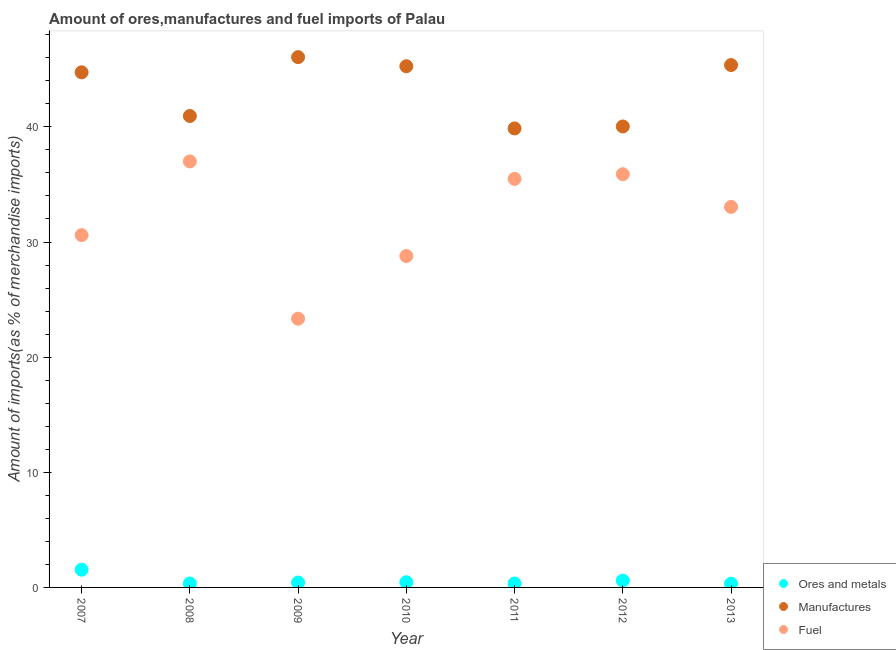What is the percentage of ores and metals imports in 2012?
Your answer should be very brief. 0.59. Across all years, what is the maximum percentage of ores and metals imports?
Give a very brief answer. 1.54. Across all years, what is the minimum percentage of ores and metals imports?
Give a very brief answer. 0.32. In which year was the percentage of manufactures imports maximum?
Ensure brevity in your answer.  2009. In which year was the percentage of ores and metals imports minimum?
Your answer should be compact. 2013. What is the total percentage of manufactures imports in the graph?
Your answer should be very brief. 302.28. What is the difference between the percentage of ores and metals imports in 2012 and that in 2013?
Make the answer very short. 0.27. What is the difference between the percentage of manufactures imports in 2009 and the percentage of ores and metals imports in 2008?
Give a very brief answer. 45.71. What is the average percentage of fuel imports per year?
Offer a very short reply. 32.02. In the year 2007, what is the difference between the percentage of manufactures imports and percentage of ores and metals imports?
Provide a succinct answer. 43.2. In how many years, is the percentage of fuel imports greater than 18 %?
Give a very brief answer. 7. What is the ratio of the percentage of ores and metals imports in 2009 to that in 2012?
Offer a terse response. 0.71. What is the difference between the highest and the second highest percentage of fuel imports?
Keep it short and to the point. 1.11. What is the difference between the highest and the lowest percentage of ores and metals imports?
Provide a succinct answer. 1.22. Is the sum of the percentage of ores and metals imports in 2010 and 2011 greater than the maximum percentage of manufactures imports across all years?
Your response must be concise. No. Is the percentage of fuel imports strictly greater than the percentage of ores and metals imports over the years?
Provide a succinct answer. Yes. Is the percentage of fuel imports strictly less than the percentage of manufactures imports over the years?
Your answer should be very brief. Yes. How many dotlines are there?
Give a very brief answer. 3. Are the values on the major ticks of Y-axis written in scientific E-notation?
Provide a short and direct response. No. How many legend labels are there?
Keep it short and to the point. 3. What is the title of the graph?
Provide a succinct answer. Amount of ores,manufactures and fuel imports of Palau. What is the label or title of the Y-axis?
Offer a terse response. Amount of imports(as % of merchandise imports). What is the Amount of imports(as % of merchandise imports) in Ores and metals in 2007?
Offer a terse response. 1.54. What is the Amount of imports(as % of merchandise imports) of Manufactures in 2007?
Make the answer very short. 44.74. What is the Amount of imports(as % of merchandise imports) in Fuel in 2007?
Your answer should be compact. 30.6. What is the Amount of imports(as % of merchandise imports) in Ores and metals in 2008?
Offer a very short reply. 0.34. What is the Amount of imports(as % of merchandise imports) of Manufactures in 2008?
Make the answer very short. 40.95. What is the Amount of imports(as % of merchandise imports) of Fuel in 2008?
Keep it short and to the point. 37. What is the Amount of imports(as % of merchandise imports) of Ores and metals in 2009?
Provide a succinct answer. 0.42. What is the Amount of imports(as % of merchandise imports) in Manufactures in 2009?
Make the answer very short. 46.06. What is the Amount of imports(as % of merchandise imports) in Fuel in 2009?
Your answer should be very brief. 23.34. What is the Amount of imports(as % of merchandise imports) in Ores and metals in 2010?
Provide a succinct answer. 0.45. What is the Amount of imports(as % of merchandise imports) of Manufactures in 2010?
Your answer should be compact. 45.27. What is the Amount of imports(as % of merchandise imports) of Fuel in 2010?
Provide a succinct answer. 28.78. What is the Amount of imports(as % of merchandise imports) of Ores and metals in 2011?
Provide a short and direct response. 0.34. What is the Amount of imports(as % of merchandise imports) of Manufactures in 2011?
Provide a succinct answer. 39.87. What is the Amount of imports(as % of merchandise imports) in Fuel in 2011?
Provide a short and direct response. 35.48. What is the Amount of imports(as % of merchandise imports) in Ores and metals in 2012?
Your response must be concise. 0.59. What is the Amount of imports(as % of merchandise imports) in Manufactures in 2012?
Give a very brief answer. 40.04. What is the Amount of imports(as % of merchandise imports) of Fuel in 2012?
Provide a short and direct response. 35.89. What is the Amount of imports(as % of merchandise imports) in Ores and metals in 2013?
Provide a short and direct response. 0.32. What is the Amount of imports(as % of merchandise imports) of Manufactures in 2013?
Provide a succinct answer. 45.37. What is the Amount of imports(as % of merchandise imports) in Fuel in 2013?
Your answer should be very brief. 33.05. Across all years, what is the maximum Amount of imports(as % of merchandise imports) in Ores and metals?
Offer a terse response. 1.54. Across all years, what is the maximum Amount of imports(as % of merchandise imports) in Manufactures?
Your answer should be compact. 46.06. Across all years, what is the maximum Amount of imports(as % of merchandise imports) in Fuel?
Your answer should be very brief. 37. Across all years, what is the minimum Amount of imports(as % of merchandise imports) of Ores and metals?
Ensure brevity in your answer.  0.32. Across all years, what is the minimum Amount of imports(as % of merchandise imports) of Manufactures?
Provide a short and direct response. 39.87. Across all years, what is the minimum Amount of imports(as % of merchandise imports) in Fuel?
Your answer should be very brief. 23.34. What is the total Amount of imports(as % of merchandise imports) of Ores and metals in the graph?
Provide a succinct answer. 4.01. What is the total Amount of imports(as % of merchandise imports) of Manufactures in the graph?
Give a very brief answer. 302.28. What is the total Amount of imports(as % of merchandise imports) of Fuel in the graph?
Your response must be concise. 224.15. What is the difference between the Amount of imports(as % of merchandise imports) of Ores and metals in 2007 and that in 2008?
Offer a terse response. 1.2. What is the difference between the Amount of imports(as % of merchandise imports) in Manufactures in 2007 and that in 2008?
Give a very brief answer. 3.79. What is the difference between the Amount of imports(as % of merchandise imports) in Fuel in 2007 and that in 2008?
Keep it short and to the point. -6.4. What is the difference between the Amount of imports(as % of merchandise imports) of Ores and metals in 2007 and that in 2009?
Provide a short and direct response. 1.12. What is the difference between the Amount of imports(as % of merchandise imports) in Manufactures in 2007 and that in 2009?
Your answer should be very brief. -1.32. What is the difference between the Amount of imports(as % of merchandise imports) in Fuel in 2007 and that in 2009?
Ensure brevity in your answer.  7.26. What is the difference between the Amount of imports(as % of merchandise imports) in Ores and metals in 2007 and that in 2010?
Provide a short and direct response. 1.09. What is the difference between the Amount of imports(as % of merchandise imports) in Manufactures in 2007 and that in 2010?
Offer a very short reply. -0.53. What is the difference between the Amount of imports(as % of merchandise imports) in Fuel in 2007 and that in 2010?
Keep it short and to the point. 1.82. What is the difference between the Amount of imports(as % of merchandise imports) of Ores and metals in 2007 and that in 2011?
Offer a terse response. 1.2. What is the difference between the Amount of imports(as % of merchandise imports) in Manufactures in 2007 and that in 2011?
Provide a succinct answer. 4.87. What is the difference between the Amount of imports(as % of merchandise imports) in Fuel in 2007 and that in 2011?
Offer a very short reply. -4.88. What is the difference between the Amount of imports(as % of merchandise imports) in Ores and metals in 2007 and that in 2012?
Ensure brevity in your answer.  0.95. What is the difference between the Amount of imports(as % of merchandise imports) in Manufactures in 2007 and that in 2012?
Your response must be concise. 4.7. What is the difference between the Amount of imports(as % of merchandise imports) of Fuel in 2007 and that in 2012?
Provide a short and direct response. -5.29. What is the difference between the Amount of imports(as % of merchandise imports) of Ores and metals in 2007 and that in 2013?
Your answer should be very brief. 1.22. What is the difference between the Amount of imports(as % of merchandise imports) of Manufactures in 2007 and that in 2013?
Offer a terse response. -0.63. What is the difference between the Amount of imports(as % of merchandise imports) of Fuel in 2007 and that in 2013?
Your answer should be very brief. -2.45. What is the difference between the Amount of imports(as % of merchandise imports) of Ores and metals in 2008 and that in 2009?
Make the answer very short. -0.08. What is the difference between the Amount of imports(as % of merchandise imports) of Manufactures in 2008 and that in 2009?
Your answer should be very brief. -5.11. What is the difference between the Amount of imports(as % of merchandise imports) in Fuel in 2008 and that in 2009?
Provide a short and direct response. 13.66. What is the difference between the Amount of imports(as % of merchandise imports) of Ores and metals in 2008 and that in 2010?
Offer a terse response. -0.11. What is the difference between the Amount of imports(as % of merchandise imports) of Manufactures in 2008 and that in 2010?
Offer a terse response. -4.32. What is the difference between the Amount of imports(as % of merchandise imports) in Fuel in 2008 and that in 2010?
Your response must be concise. 8.21. What is the difference between the Amount of imports(as % of merchandise imports) of Ores and metals in 2008 and that in 2011?
Make the answer very short. 0. What is the difference between the Amount of imports(as % of merchandise imports) in Manufactures in 2008 and that in 2011?
Provide a short and direct response. 1.08. What is the difference between the Amount of imports(as % of merchandise imports) of Fuel in 2008 and that in 2011?
Offer a terse response. 1.52. What is the difference between the Amount of imports(as % of merchandise imports) of Ores and metals in 2008 and that in 2012?
Your answer should be very brief. -0.25. What is the difference between the Amount of imports(as % of merchandise imports) in Manufactures in 2008 and that in 2012?
Offer a very short reply. 0.91. What is the difference between the Amount of imports(as % of merchandise imports) in Fuel in 2008 and that in 2012?
Offer a very short reply. 1.11. What is the difference between the Amount of imports(as % of merchandise imports) in Ores and metals in 2008 and that in 2013?
Offer a terse response. 0.02. What is the difference between the Amount of imports(as % of merchandise imports) in Manufactures in 2008 and that in 2013?
Ensure brevity in your answer.  -4.42. What is the difference between the Amount of imports(as % of merchandise imports) of Fuel in 2008 and that in 2013?
Provide a short and direct response. 3.95. What is the difference between the Amount of imports(as % of merchandise imports) in Ores and metals in 2009 and that in 2010?
Your response must be concise. -0.03. What is the difference between the Amount of imports(as % of merchandise imports) in Manufactures in 2009 and that in 2010?
Ensure brevity in your answer.  0.79. What is the difference between the Amount of imports(as % of merchandise imports) in Fuel in 2009 and that in 2010?
Your answer should be compact. -5.44. What is the difference between the Amount of imports(as % of merchandise imports) of Ores and metals in 2009 and that in 2011?
Make the answer very short. 0.08. What is the difference between the Amount of imports(as % of merchandise imports) of Manufactures in 2009 and that in 2011?
Keep it short and to the point. 6.19. What is the difference between the Amount of imports(as % of merchandise imports) of Fuel in 2009 and that in 2011?
Make the answer very short. -12.14. What is the difference between the Amount of imports(as % of merchandise imports) in Ores and metals in 2009 and that in 2012?
Keep it short and to the point. -0.17. What is the difference between the Amount of imports(as % of merchandise imports) of Manufactures in 2009 and that in 2012?
Offer a very short reply. 6.02. What is the difference between the Amount of imports(as % of merchandise imports) of Fuel in 2009 and that in 2012?
Keep it short and to the point. -12.54. What is the difference between the Amount of imports(as % of merchandise imports) in Ores and metals in 2009 and that in 2013?
Keep it short and to the point. 0.1. What is the difference between the Amount of imports(as % of merchandise imports) in Manufactures in 2009 and that in 2013?
Your answer should be very brief. 0.69. What is the difference between the Amount of imports(as % of merchandise imports) in Fuel in 2009 and that in 2013?
Keep it short and to the point. -9.71. What is the difference between the Amount of imports(as % of merchandise imports) of Ores and metals in 2010 and that in 2011?
Keep it short and to the point. 0.11. What is the difference between the Amount of imports(as % of merchandise imports) in Manufactures in 2010 and that in 2011?
Provide a short and direct response. 5.4. What is the difference between the Amount of imports(as % of merchandise imports) of Fuel in 2010 and that in 2011?
Ensure brevity in your answer.  -6.7. What is the difference between the Amount of imports(as % of merchandise imports) in Ores and metals in 2010 and that in 2012?
Offer a terse response. -0.14. What is the difference between the Amount of imports(as % of merchandise imports) of Manufactures in 2010 and that in 2012?
Make the answer very short. 5.23. What is the difference between the Amount of imports(as % of merchandise imports) in Fuel in 2010 and that in 2012?
Provide a succinct answer. -7.1. What is the difference between the Amount of imports(as % of merchandise imports) of Ores and metals in 2010 and that in 2013?
Ensure brevity in your answer.  0.13. What is the difference between the Amount of imports(as % of merchandise imports) in Manufactures in 2010 and that in 2013?
Your answer should be compact. -0.1. What is the difference between the Amount of imports(as % of merchandise imports) in Fuel in 2010 and that in 2013?
Your response must be concise. -4.27. What is the difference between the Amount of imports(as % of merchandise imports) in Ores and metals in 2011 and that in 2012?
Provide a succinct answer. -0.25. What is the difference between the Amount of imports(as % of merchandise imports) in Manufactures in 2011 and that in 2012?
Ensure brevity in your answer.  -0.17. What is the difference between the Amount of imports(as % of merchandise imports) of Fuel in 2011 and that in 2012?
Offer a very short reply. -0.4. What is the difference between the Amount of imports(as % of merchandise imports) of Ores and metals in 2011 and that in 2013?
Your response must be concise. 0.02. What is the difference between the Amount of imports(as % of merchandise imports) of Manufactures in 2011 and that in 2013?
Keep it short and to the point. -5.5. What is the difference between the Amount of imports(as % of merchandise imports) of Fuel in 2011 and that in 2013?
Give a very brief answer. 2.43. What is the difference between the Amount of imports(as % of merchandise imports) in Ores and metals in 2012 and that in 2013?
Make the answer very short. 0.27. What is the difference between the Amount of imports(as % of merchandise imports) in Manufactures in 2012 and that in 2013?
Provide a short and direct response. -5.33. What is the difference between the Amount of imports(as % of merchandise imports) in Fuel in 2012 and that in 2013?
Keep it short and to the point. 2.84. What is the difference between the Amount of imports(as % of merchandise imports) of Ores and metals in 2007 and the Amount of imports(as % of merchandise imports) of Manufactures in 2008?
Provide a succinct answer. -39.41. What is the difference between the Amount of imports(as % of merchandise imports) in Ores and metals in 2007 and the Amount of imports(as % of merchandise imports) in Fuel in 2008?
Offer a very short reply. -35.46. What is the difference between the Amount of imports(as % of merchandise imports) in Manufactures in 2007 and the Amount of imports(as % of merchandise imports) in Fuel in 2008?
Make the answer very short. 7.74. What is the difference between the Amount of imports(as % of merchandise imports) of Ores and metals in 2007 and the Amount of imports(as % of merchandise imports) of Manufactures in 2009?
Provide a short and direct response. -44.52. What is the difference between the Amount of imports(as % of merchandise imports) in Ores and metals in 2007 and the Amount of imports(as % of merchandise imports) in Fuel in 2009?
Offer a terse response. -21.8. What is the difference between the Amount of imports(as % of merchandise imports) of Manufactures in 2007 and the Amount of imports(as % of merchandise imports) of Fuel in 2009?
Your response must be concise. 21.4. What is the difference between the Amount of imports(as % of merchandise imports) in Ores and metals in 2007 and the Amount of imports(as % of merchandise imports) in Manufactures in 2010?
Provide a succinct answer. -43.73. What is the difference between the Amount of imports(as % of merchandise imports) in Ores and metals in 2007 and the Amount of imports(as % of merchandise imports) in Fuel in 2010?
Provide a succinct answer. -27.24. What is the difference between the Amount of imports(as % of merchandise imports) of Manufactures in 2007 and the Amount of imports(as % of merchandise imports) of Fuel in 2010?
Your answer should be very brief. 15.96. What is the difference between the Amount of imports(as % of merchandise imports) in Ores and metals in 2007 and the Amount of imports(as % of merchandise imports) in Manufactures in 2011?
Your answer should be compact. -38.33. What is the difference between the Amount of imports(as % of merchandise imports) in Ores and metals in 2007 and the Amount of imports(as % of merchandise imports) in Fuel in 2011?
Ensure brevity in your answer.  -33.94. What is the difference between the Amount of imports(as % of merchandise imports) of Manufactures in 2007 and the Amount of imports(as % of merchandise imports) of Fuel in 2011?
Keep it short and to the point. 9.26. What is the difference between the Amount of imports(as % of merchandise imports) of Ores and metals in 2007 and the Amount of imports(as % of merchandise imports) of Manufactures in 2012?
Make the answer very short. -38.5. What is the difference between the Amount of imports(as % of merchandise imports) in Ores and metals in 2007 and the Amount of imports(as % of merchandise imports) in Fuel in 2012?
Provide a succinct answer. -34.35. What is the difference between the Amount of imports(as % of merchandise imports) of Manufactures in 2007 and the Amount of imports(as % of merchandise imports) of Fuel in 2012?
Your response must be concise. 8.85. What is the difference between the Amount of imports(as % of merchandise imports) of Ores and metals in 2007 and the Amount of imports(as % of merchandise imports) of Manufactures in 2013?
Your answer should be very brief. -43.83. What is the difference between the Amount of imports(as % of merchandise imports) in Ores and metals in 2007 and the Amount of imports(as % of merchandise imports) in Fuel in 2013?
Your answer should be very brief. -31.51. What is the difference between the Amount of imports(as % of merchandise imports) of Manufactures in 2007 and the Amount of imports(as % of merchandise imports) of Fuel in 2013?
Keep it short and to the point. 11.69. What is the difference between the Amount of imports(as % of merchandise imports) in Ores and metals in 2008 and the Amount of imports(as % of merchandise imports) in Manufactures in 2009?
Your answer should be very brief. -45.71. What is the difference between the Amount of imports(as % of merchandise imports) in Ores and metals in 2008 and the Amount of imports(as % of merchandise imports) in Fuel in 2009?
Your answer should be compact. -23. What is the difference between the Amount of imports(as % of merchandise imports) of Manufactures in 2008 and the Amount of imports(as % of merchandise imports) of Fuel in 2009?
Provide a succinct answer. 17.6. What is the difference between the Amount of imports(as % of merchandise imports) in Ores and metals in 2008 and the Amount of imports(as % of merchandise imports) in Manufactures in 2010?
Offer a terse response. -44.92. What is the difference between the Amount of imports(as % of merchandise imports) in Ores and metals in 2008 and the Amount of imports(as % of merchandise imports) in Fuel in 2010?
Make the answer very short. -28.44. What is the difference between the Amount of imports(as % of merchandise imports) in Manufactures in 2008 and the Amount of imports(as % of merchandise imports) in Fuel in 2010?
Your response must be concise. 12.16. What is the difference between the Amount of imports(as % of merchandise imports) of Ores and metals in 2008 and the Amount of imports(as % of merchandise imports) of Manufactures in 2011?
Ensure brevity in your answer.  -39.52. What is the difference between the Amount of imports(as % of merchandise imports) in Ores and metals in 2008 and the Amount of imports(as % of merchandise imports) in Fuel in 2011?
Make the answer very short. -35.14. What is the difference between the Amount of imports(as % of merchandise imports) in Manufactures in 2008 and the Amount of imports(as % of merchandise imports) in Fuel in 2011?
Make the answer very short. 5.46. What is the difference between the Amount of imports(as % of merchandise imports) of Ores and metals in 2008 and the Amount of imports(as % of merchandise imports) of Manufactures in 2012?
Give a very brief answer. -39.69. What is the difference between the Amount of imports(as % of merchandise imports) of Ores and metals in 2008 and the Amount of imports(as % of merchandise imports) of Fuel in 2012?
Make the answer very short. -35.55. What is the difference between the Amount of imports(as % of merchandise imports) of Manufactures in 2008 and the Amount of imports(as % of merchandise imports) of Fuel in 2012?
Provide a short and direct response. 5.06. What is the difference between the Amount of imports(as % of merchandise imports) of Ores and metals in 2008 and the Amount of imports(as % of merchandise imports) of Manufactures in 2013?
Give a very brief answer. -45.03. What is the difference between the Amount of imports(as % of merchandise imports) in Ores and metals in 2008 and the Amount of imports(as % of merchandise imports) in Fuel in 2013?
Offer a terse response. -32.71. What is the difference between the Amount of imports(as % of merchandise imports) of Manufactures in 2008 and the Amount of imports(as % of merchandise imports) of Fuel in 2013?
Your answer should be compact. 7.9. What is the difference between the Amount of imports(as % of merchandise imports) of Ores and metals in 2009 and the Amount of imports(as % of merchandise imports) of Manufactures in 2010?
Your answer should be compact. -44.84. What is the difference between the Amount of imports(as % of merchandise imports) in Ores and metals in 2009 and the Amount of imports(as % of merchandise imports) in Fuel in 2010?
Give a very brief answer. -28.36. What is the difference between the Amount of imports(as % of merchandise imports) of Manufactures in 2009 and the Amount of imports(as % of merchandise imports) of Fuel in 2010?
Make the answer very short. 17.27. What is the difference between the Amount of imports(as % of merchandise imports) in Ores and metals in 2009 and the Amount of imports(as % of merchandise imports) in Manufactures in 2011?
Provide a succinct answer. -39.44. What is the difference between the Amount of imports(as % of merchandise imports) of Ores and metals in 2009 and the Amount of imports(as % of merchandise imports) of Fuel in 2011?
Your answer should be compact. -35.06. What is the difference between the Amount of imports(as % of merchandise imports) of Manufactures in 2009 and the Amount of imports(as % of merchandise imports) of Fuel in 2011?
Keep it short and to the point. 10.57. What is the difference between the Amount of imports(as % of merchandise imports) in Ores and metals in 2009 and the Amount of imports(as % of merchandise imports) in Manufactures in 2012?
Give a very brief answer. -39.61. What is the difference between the Amount of imports(as % of merchandise imports) of Ores and metals in 2009 and the Amount of imports(as % of merchandise imports) of Fuel in 2012?
Make the answer very short. -35.46. What is the difference between the Amount of imports(as % of merchandise imports) in Manufactures in 2009 and the Amount of imports(as % of merchandise imports) in Fuel in 2012?
Your answer should be compact. 10.17. What is the difference between the Amount of imports(as % of merchandise imports) of Ores and metals in 2009 and the Amount of imports(as % of merchandise imports) of Manufactures in 2013?
Give a very brief answer. -44.95. What is the difference between the Amount of imports(as % of merchandise imports) of Ores and metals in 2009 and the Amount of imports(as % of merchandise imports) of Fuel in 2013?
Keep it short and to the point. -32.63. What is the difference between the Amount of imports(as % of merchandise imports) in Manufactures in 2009 and the Amount of imports(as % of merchandise imports) in Fuel in 2013?
Make the answer very short. 13.01. What is the difference between the Amount of imports(as % of merchandise imports) in Ores and metals in 2010 and the Amount of imports(as % of merchandise imports) in Manufactures in 2011?
Your response must be concise. -39.42. What is the difference between the Amount of imports(as % of merchandise imports) in Ores and metals in 2010 and the Amount of imports(as % of merchandise imports) in Fuel in 2011?
Offer a terse response. -35.03. What is the difference between the Amount of imports(as % of merchandise imports) of Manufactures in 2010 and the Amount of imports(as % of merchandise imports) of Fuel in 2011?
Offer a terse response. 9.78. What is the difference between the Amount of imports(as % of merchandise imports) in Ores and metals in 2010 and the Amount of imports(as % of merchandise imports) in Manufactures in 2012?
Offer a terse response. -39.59. What is the difference between the Amount of imports(as % of merchandise imports) of Ores and metals in 2010 and the Amount of imports(as % of merchandise imports) of Fuel in 2012?
Offer a very short reply. -35.44. What is the difference between the Amount of imports(as % of merchandise imports) of Manufactures in 2010 and the Amount of imports(as % of merchandise imports) of Fuel in 2012?
Offer a terse response. 9.38. What is the difference between the Amount of imports(as % of merchandise imports) of Ores and metals in 2010 and the Amount of imports(as % of merchandise imports) of Manufactures in 2013?
Give a very brief answer. -44.92. What is the difference between the Amount of imports(as % of merchandise imports) of Ores and metals in 2010 and the Amount of imports(as % of merchandise imports) of Fuel in 2013?
Make the answer very short. -32.6. What is the difference between the Amount of imports(as % of merchandise imports) in Manufactures in 2010 and the Amount of imports(as % of merchandise imports) in Fuel in 2013?
Your answer should be very brief. 12.22. What is the difference between the Amount of imports(as % of merchandise imports) of Ores and metals in 2011 and the Amount of imports(as % of merchandise imports) of Manufactures in 2012?
Make the answer very short. -39.7. What is the difference between the Amount of imports(as % of merchandise imports) of Ores and metals in 2011 and the Amount of imports(as % of merchandise imports) of Fuel in 2012?
Make the answer very short. -35.55. What is the difference between the Amount of imports(as % of merchandise imports) in Manufactures in 2011 and the Amount of imports(as % of merchandise imports) in Fuel in 2012?
Your answer should be very brief. 3.98. What is the difference between the Amount of imports(as % of merchandise imports) of Ores and metals in 2011 and the Amount of imports(as % of merchandise imports) of Manufactures in 2013?
Give a very brief answer. -45.03. What is the difference between the Amount of imports(as % of merchandise imports) of Ores and metals in 2011 and the Amount of imports(as % of merchandise imports) of Fuel in 2013?
Your answer should be very brief. -32.71. What is the difference between the Amount of imports(as % of merchandise imports) in Manufactures in 2011 and the Amount of imports(as % of merchandise imports) in Fuel in 2013?
Provide a short and direct response. 6.82. What is the difference between the Amount of imports(as % of merchandise imports) in Ores and metals in 2012 and the Amount of imports(as % of merchandise imports) in Manufactures in 2013?
Your answer should be very brief. -44.78. What is the difference between the Amount of imports(as % of merchandise imports) in Ores and metals in 2012 and the Amount of imports(as % of merchandise imports) in Fuel in 2013?
Offer a terse response. -32.46. What is the difference between the Amount of imports(as % of merchandise imports) in Manufactures in 2012 and the Amount of imports(as % of merchandise imports) in Fuel in 2013?
Make the answer very short. 6.99. What is the average Amount of imports(as % of merchandise imports) of Ores and metals per year?
Your answer should be very brief. 0.57. What is the average Amount of imports(as % of merchandise imports) in Manufactures per year?
Provide a short and direct response. 43.18. What is the average Amount of imports(as % of merchandise imports) of Fuel per year?
Keep it short and to the point. 32.02. In the year 2007, what is the difference between the Amount of imports(as % of merchandise imports) in Ores and metals and Amount of imports(as % of merchandise imports) in Manufactures?
Your response must be concise. -43.2. In the year 2007, what is the difference between the Amount of imports(as % of merchandise imports) in Ores and metals and Amount of imports(as % of merchandise imports) in Fuel?
Give a very brief answer. -29.06. In the year 2007, what is the difference between the Amount of imports(as % of merchandise imports) in Manufactures and Amount of imports(as % of merchandise imports) in Fuel?
Make the answer very short. 14.14. In the year 2008, what is the difference between the Amount of imports(as % of merchandise imports) of Ores and metals and Amount of imports(as % of merchandise imports) of Manufactures?
Your answer should be very brief. -40.61. In the year 2008, what is the difference between the Amount of imports(as % of merchandise imports) in Ores and metals and Amount of imports(as % of merchandise imports) in Fuel?
Your answer should be compact. -36.66. In the year 2008, what is the difference between the Amount of imports(as % of merchandise imports) of Manufactures and Amount of imports(as % of merchandise imports) of Fuel?
Your response must be concise. 3.95. In the year 2009, what is the difference between the Amount of imports(as % of merchandise imports) of Ores and metals and Amount of imports(as % of merchandise imports) of Manufactures?
Your response must be concise. -45.63. In the year 2009, what is the difference between the Amount of imports(as % of merchandise imports) in Ores and metals and Amount of imports(as % of merchandise imports) in Fuel?
Your answer should be compact. -22.92. In the year 2009, what is the difference between the Amount of imports(as % of merchandise imports) of Manufactures and Amount of imports(as % of merchandise imports) of Fuel?
Keep it short and to the point. 22.71. In the year 2010, what is the difference between the Amount of imports(as % of merchandise imports) in Ores and metals and Amount of imports(as % of merchandise imports) in Manufactures?
Offer a very short reply. -44.82. In the year 2010, what is the difference between the Amount of imports(as % of merchandise imports) of Ores and metals and Amount of imports(as % of merchandise imports) of Fuel?
Offer a very short reply. -28.33. In the year 2010, what is the difference between the Amount of imports(as % of merchandise imports) in Manufactures and Amount of imports(as % of merchandise imports) in Fuel?
Your answer should be very brief. 16.48. In the year 2011, what is the difference between the Amount of imports(as % of merchandise imports) in Ores and metals and Amount of imports(as % of merchandise imports) in Manufactures?
Your answer should be very brief. -39.53. In the year 2011, what is the difference between the Amount of imports(as % of merchandise imports) in Ores and metals and Amount of imports(as % of merchandise imports) in Fuel?
Your answer should be very brief. -35.14. In the year 2011, what is the difference between the Amount of imports(as % of merchandise imports) of Manufactures and Amount of imports(as % of merchandise imports) of Fuel?
Your answer should be compact. 4.38. In the year 2012, what is the difference between the Amount of imports(as % of merchandise imports) in Ores and metals and Amount of imports(as % of merchandise imports) in Manufactures?
Provide a short and direct response. -39.44. In the year 2012, what is the difference between the Amount of imports(as % of merchandise imports) of Ores and metals and Amount of imports(as % of merchandise imports) of Fuel?
Offer a very short reply. -35.29. In the year 2012, what is the difference between the Amount of imports(as % of merchandise imports) in Manufactures and Amount of imports(as % of merchandise imports) in Fuel?
Provide a short and direct response. 4.15. In the year 2013, what is the difference between the Amount of imports(as % of merchandise imports) in Ores and metals and Amount of imports(as % of merchandise imports) in Manufactures?
Offer a terse response. -45.05. In the year 2013, what is the difference between the Amount of imports(as % of merchandise imports) of Ores and metals and Amount of imports(as % of merchandise imports) of Fuel?
Offer a very short reply. -32.73. In the year 2013, what is the difference between the Amount of imports(as % of merchandise imports) in Manufactures and Amount of imports(as % of merchandise imports) in Fuel?
Offer a terse response. 12.32. What is the ratio of the Amount of imports(as % of merchandise imports) in Ores and metals in 2007 to that in 2008?
Provide a short and direct response. 4.51. What is the ratio of the Amount of imports(as % of merchandise imports) in Manufactures in 2007 to that in 2008?
Ensure brevity in your answer.  1.09. What is the ratio of the Amount of imports(as % of merchandise imports) in Fuel in 2007 to that in 2008?
Offer a terse response. 0.83. What is the ratio of the Amount of imports(as % of merchandise imports) in Ores and metals in 2007 to that in 2009?
Your response must be concise. 3.64. What is the ratio of the Amount of imports(as % of merchandise imports) in Manufactures in 2007 to that in 2009?
Give a very brief answer. 0.97. What is the ratio of the Amount of imports(as % of merchandise imports) in Fuel in 2007 to that in 2009?
Offer a very short reply. 1.31. What is the ratio of the Amount of imports(as % of merchandise imports) in Ores and metals in 2007 to that in 2010?
Offer a terse response. 3.42. What is the ratio of the Amount of imports(as % of merchandise imports) in Manufactures in 2007 to that in 2010?
Give a very brief answer. 0.99. What is the ratio of the Amount of imports(as % of merchandise imports) of Fuel in 2007 to that in 2010?
Ensure brevity in your answer.  1.06. What is the ratio of the Amount of imports(as % of merchandise imports) of Ores and metals in 2007 to that in 2011?
Give a very brief answer. 4.53. What is the ratio of the Amount of imports(as % of merchandise imports) of Manufactures in 2007 to that in 2011?
Keep it short and to the point. 1.12. What is the ratio of the Amount of imports(as % of merchandise imports) of Fuel in 2007 to that in 2011?
Keep it short and to the point. 0.86. What is the ratio of the Amount of imports(as % of merchandise imports) in Ores and metals in 2007 to that in 2012?
Ensure brevity in your answer.  2.6. What is the ratio of the Amount of imports(as % of merchandise imports) in Manufactures in 2007 to that in 2012?
Your answer should be very brief. 1.12. What is the ratio of the Amount of imports(as % of merchandise imports) of Fuel in 2007 to that in 2012?
Offer a terse response. 0.85. What is the ratio of the Amount of imports(as % of merchandise imports) of Ores and metals in 2007 to that in 2013?
Provide a short and direct response. 4.79. What is the ratio of the Amount of imports(as % of merchandise imports) in Manufactures in 2007 to that in 2013?
Your answer should be very brief. 0.99. What is the ratio of the Amount of imports(as % of merchandise imports) of Fuel in 2007 to that in 2013?
Your answer should be very brief. 0.93. What is the ratio of the Amount of imports(as % of merchandise imports) of Ores and metals in 2008 to that in 2009?
Make the answer very short. 0.81. What is the ratio of the Amount of imports(as % of merchandise imports) of Manufactures in 2008 to that in 2009?
Ensure brevity in your answer.  0.89. What is the ratio of the Amount of imports(as % of merchandise imports) of Fuel in 2008 to that in 2009?
Provide a short and direct response. 1.58. What is the ratio of the Amount of imports(as % of merchandise imports) in Ores and metals in 2008 to that in 2010?
Your answer should be compact. 0.76. What is the ratio of the Amount of imports(as % of merchandise imports) in Manufactures in 2008 to that in 2010?
Your response must be concise. 0.9. What is the ratio of the Amount of imports(as % of merchandise imports) in Fuel in 2008 to that in 2010?
Your answer should be compact. 1.29. What is the ratio of the Amount of imports(as % of merchandise imports) of Manufactures in 2008 to that in 2011?
Give a very brief answer. 1.03. What is the ratio of the Amount of imports(as % of merchandise imports) in Fuel in 2008 to that in 2011?
Your answer should be compact. 1.04. What is the ratio of the Amount of imports(as % of merchandise imports) of Ores and metals in 2008 to that in 2012?
Your answer should be compact. 0.58. What is the ratio of the Amount of imports(as % of merchandise imports) in Manufactures in 2008 to that in 2012?
Your response must be concise. 1.02. What is the ratio of the Amount of imports(as % of merchandise imports) in Fuel in 2008 to that in 2012?
Keep it short and to the point. 1.03. What is the ratio of the Amount of imports(as % of merchandise imports) in Ores and metals in 2008 to that in 2013?
Provide a succinct answer. 1.06. What is the ratio of the Amount of imports(as % of merchandise imports) of Manufactures in 2008 to that in 2013?
Your answer should be compact. 0.9. What is the ratio of the Amount of imports(as % of merchandise imports) of Fuel in 2008 to that in 2013?
Your answer should be compact. 1.12. What is the ratio of the Amount of imports(as % of merchandise imports) in Ores and metals in 2009 to that in 2010?
Give a very brief answer. 0.94. What is the ratio of the Amount of imports(as % of merchandise imports) in Manufactures in 2009 to that in 2010?
Make the answer very short. 1.02. What is the ratio of the Amount of imports(as % of merchandise imports) in Fuel in 2009 to that in 2010?
Keep it short and to the point. 0.81. What is the ratio of the Amount of imports(as % of merchandise imports) of Ores and metals in 2009 to that in 2011?
Your answer should be very brief. 1.24. What is the ratio of the Amount of imports(as % of merchandise imports) of Manufactures in 2009 to that in 2011?
Your answer should be very brief. 1.16. What is the ratio of the Amount of imports(as % of merchandise imports) in Fuel in 2009 to that in 2011?
Offer a terse response. 0.66. What is the ratio of the Amount of imports(as % of merchandise imports) in Ores and metals in 2009 to that in 2012?
Give a very brief answer. 0.71. What is the ratio of the Amount of imports(as % of merchandise imports) of Manufactures in 2009 to that in 2012?
Provide a succinct answer. 1.15. What is the ratio of the Amount of imports(as % of merchandise imports) in Fuel in 2009 to that in 2012?
Ensure brevity in your answer.  0.65. What is the ratio of the Amount of imports(as % of merchandise imports) in Ores and metals in 2009 to that in 2013?
Provide a short and direct response. 1.32. What is the ratio of the Amount of imports(as % of merchandise imports) in Manufactures in 2009 to that in 2013?
Your answer should be compact. 1.02. What is the ratio of the Amount of imports(as % of merchandise imports) of Fuel in 2009 to that in 2013?
Ensure brevity in your answer.  0.71. What is the ratio of the Amount of imports(as % of merchandise imports) of Ores and metals in 2010 to that in 2011?
Ensure brevity in your answer.  1.32. What is the ratio of the Amount of imports(as % of merchandise imports) in Manufactures in 2010 to that in 2011?
Provide a succinct answer. 1.14. What is the ratio of the Amount of imports(as % of merchandise imports) in Fuel in 2010 to that in 2011?
Make the answer very short. 0.81. What is the ratio of the Amount of imports(as % of merchandise imports) of Ores and metals in 2010 to that in 2012?
Provide a short and direct response. 0.76. What is the ratio of the Amount of imports(as % of merchandise imports) in Manufactures in 2010 to that in 2012?
Provide a succinct answer. 1.13. What is the ratio of the Amount of imports(as % of merchandise imports) of Fuel in 2010 to that in 2012?
Offer a very short reply. 0.8. What is the ratio of the Amount of imports(as % of merchandise imports) of Ores and metals in 2010 to that in 2013?
Offer a very short reply. 1.4. What is the ratio of the Amount of imports(as % of merchandise imports) in Manufactures in 2010 to that in 2013?
Offer a terse response. 1. What is the ratio of the Amount of imports(as % of merchandise imports) of Fuel in 2010 to that in 2013?
Offer a very short reply. 0.87. What is the ratio of the Amount of imports(as % of merchandise imports) of Ores and metals in 2011 to that in 2012?
Offer a very short reply. 0.57. What is the ratio of the Amount of imports(as % of merchandise imports) in Manufactures in 2011 to that in 2012?
Ensure brevity in your answer.  1. What is the ratio of the Amount of imports(as % of merchandise imports) of Fuel in 2011 to that in 2012?
Your answer should be very brief. 0.99. What is the ratio of the Amount of imports(as % of merchandise imports) in Ores and metals in 2011 to that in 2013?
Ensure brevity in your answer.  1.06. What is the ratio of the Amount of imports(as % of merchandise imports) of Manufactures in 2011 to that in 2013?
Offer a terse response. 0.88. What is the ratio of the Amount of imports(as % of merchandise imports) of Fuel in 2011 to that in 2013?
Offer a very short reply. 1.07. What is the ratio of the Amount of imports(as % of merchandise imports) of Ores and metals in 2012 to that in 2013?
Your answer should be compact. 1.84. What is the ratio of the Amount of imports(as % of merchandise imports) in Manufactures in 2012 to that in 2013?
Give a very brief answer. 0.88. What is the ratio of the Amount of imports(as % of merchandise imports) in Fuel in 2012 to that in 2013?
Provide a succinct answer. 1.09. What is the difference between the highest and the second highest Amount of imports(as % of merchandise imports) of Ores and metals?
Provide a short and direct response. 0.95. What is the difference between the highest and the second highest Amount of imports(as % of merchandise imports) of Manufactures?
Provide a short and direct response. 0.69. What is the difference between the highest and the second highest Amount of imports(as % of merchandise imports) of Fuel?
Provide a short and direct response. 1.11. What is the difference between the highest and the lowest Amount of imports(as % of merchandise imports) of Ores and metals?
Your response must be concise. 1.22. What is the difference between the highest and the lowest Amount of imports(as % of merchandise imports) in Manufactures?
Give a very brief answer. 6.19. What is the difference between the highest and the lowest Amount of imports(as % of merchandise imports) in Fuel?
Your response must be concise. 13.66. 